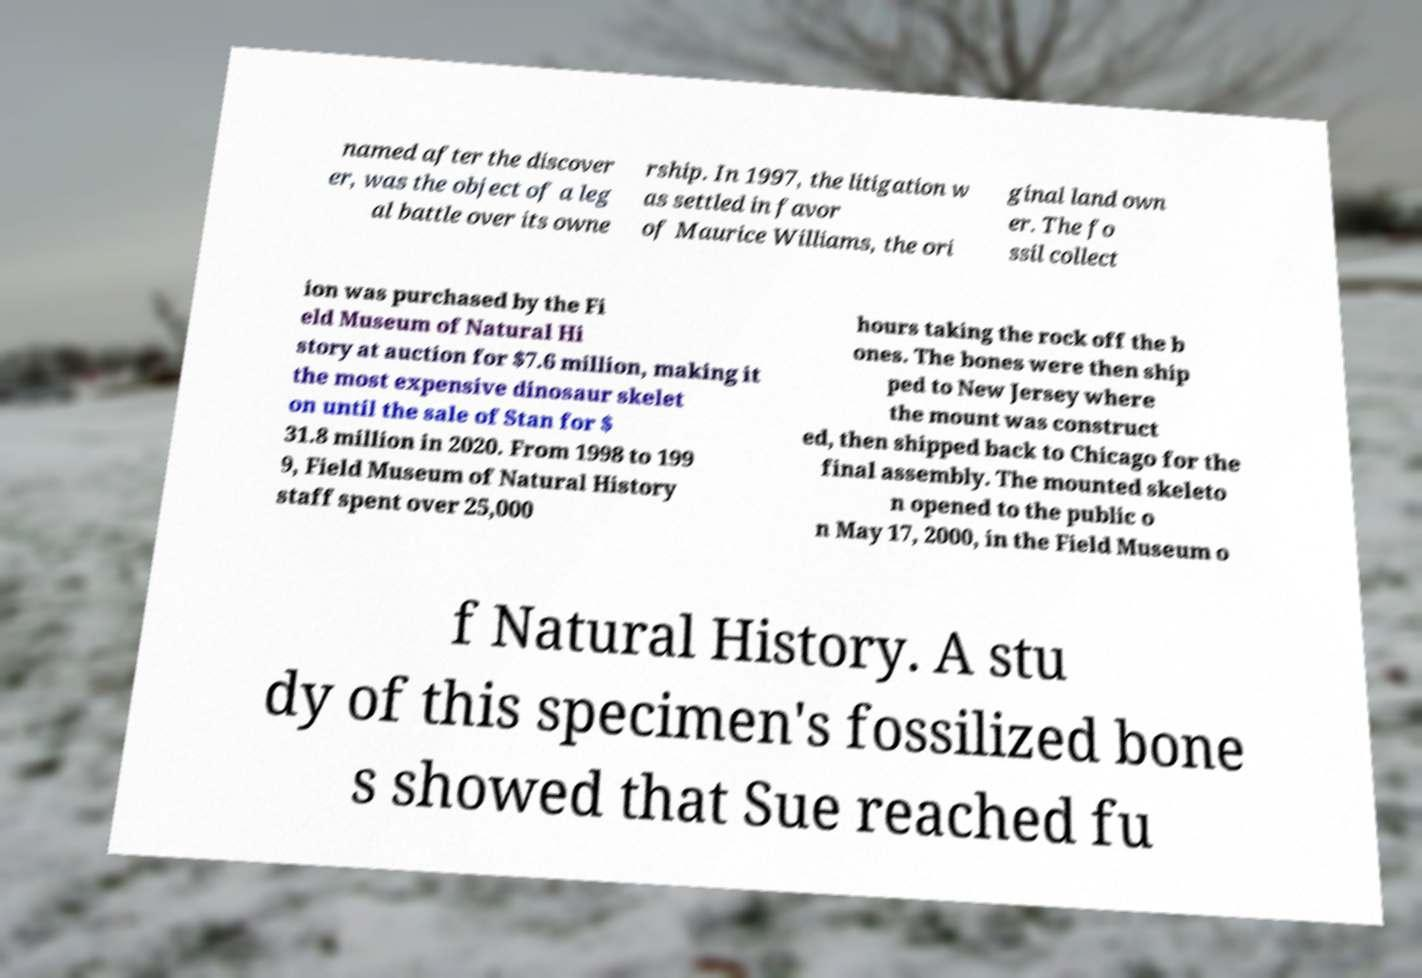Please identify and transcribe the text found in this image. named after the discover er, was the object of a leg al battle over its owne rship. In 1997, the litigation w as settled in favor of Maurice Williams, the ori ginal land own er. The fo ssil collect ion was purchased by the Fi eld Museum of Natural Hi story at auction for $7.6 million, making it the most expensive dinosaur skelet on until the sale of Stan for $ 31.8 million in 2020. From 1998 to 199 9, Field Museum of Natural History staff spent over 25,000 hours taking the rock off the b ones. The bones were then ship ped to New Jersey where the mount was construct ed, then shipped back to Chicago for the final assembly. The mounted skeleto n opened to the public o n May 17, 2000, in the Field Museum o f Natural History. A stu dy of this specimen's fossilized bone s showed that Sue reached fu 